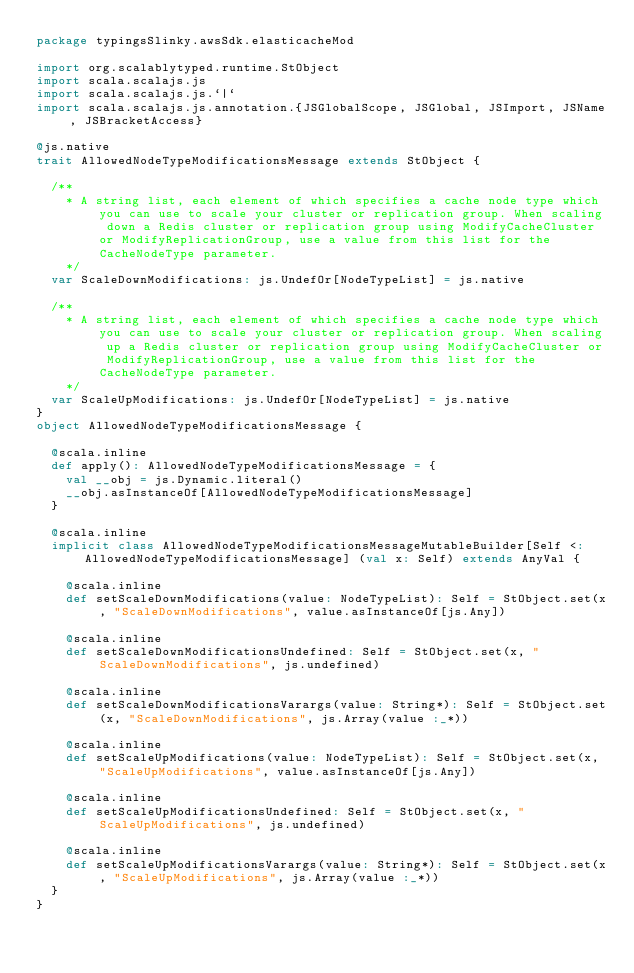Convert code to text. <code><loc_0><loc_0><loc_500><loc_500><_Scala_>package typingsSlinky.awsSdk.elasticacheMod

import org.scalablytyped.runtime.StObject
import scala.scalajs.js
import scala.scalajs.js.`|`
import scala.scalajs.js.annotation.{JSGlobalScope, JSGlobal, JSImport, JSName, JSBracketAccess}

@js.native
trait AllowedNodeTypeModificationsMessage extends StObject {
  
  /**
    * A string list, each element of which specifies a cache node type which you can use to scale your cluster or replication group. When scaling down a Redis cluster or replication group using ModifyCacheCluster or ModifyReplicationGroup, use a value from this list for the CacheNodeType parameter. 
    */
  var ScaleDownModifications: js.UndefOr[NodeTypeList] = js.native
  
  /**
    * A string list, each element of which specifies a cache node type which you can use to scale your cluster or replication group. When scaling up a Redis cluster or replication group using ModifyCacheCluster or ModifyReplicationGroup, use a value from this list for the CacheNodeType parameter.
    */
  var ScaleUpModifications: js.UndefOr[NodeTypeList] = js.native
}
object AllowedNodeTypeModificationsMessage {
  
  @scala.inline
  def apply(): AllowedNodeTypeModificationsMessage = {
    val __obj = js.Dynamic.literal()
    __obj.asInstanceOf[AllowedNodeTypeModificationsMessage]
  }
  
  @scala.inline
  implicit class AllowedNodeTypeModificationsMessageMutableBuilder[Self <: AllowedNodeTypeModificationsMessage] (val x: Self) extends AnyVal {
    
    @scala.inline
    def setScaleDownModifications(value: NodeTypeList): Self = StObject.set(x, "ScaleDownModifications", value.asInstanceOf[js.Any])
    
    @scala.inline
    def setScaleDownModificationsUndefined: Self = StObject.set(x, "ScaleDownModifications", js.undefined)
    
    @scala.inline
    def setScaleDownModificationsVarargs(value: String*): Self = StObject.set(x, "ScaleDownModifications", js.Array(value :_*))
    
    @scala.inline
    def setScaleUpModifications(value: NodeTypeList): Self = StObject.set(x, "ScaleUpModifications", value.asInstanceOf[js.Any])
    
    @scala.inline
    def setScaleUpModificationsUndefined: Self = StObject.set(x, "ScaleUpModifications", js.undefined)
    
    @scala.inline
    def setScaleUpModificationsVarargs(value: String*): Self = StObject.set(x, "ScaleUpModifications", js.Array(value :_*))
  }
}
</code> 